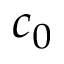Convert formula to latex. <formula><loc_0><loc_0><loc_500><loc_500>c _ { 0 }</formula> 